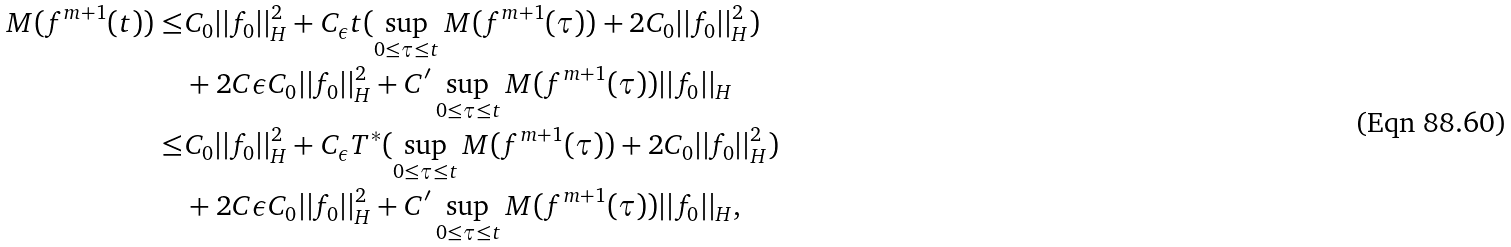Convert formula to latex. <formula><loc_0><loc_0><loc_500><loc_500>M ( f ^ { m + 1 } ( t ) ) \leq & C _ { 0 } | | f _ { 0 } | | ^ { 2 } _ { H } + C _ { \epsilon } t ( \sup _ { 0 \leq \tau \leq t } M ( f ^ { m + 1 } ( \tau ) ) + 2 C _ { 0 } | | f _ { 0 } | | ^ { 2 } _ { H } ) \\ & + 2 C \epsilon C _ { 0 } | | f _ { 0 } | | ^ { 2 } _ { H } + C ^ { \prime } \sup _ { 0 \leq \tau \leq t } M ( f ^ { m + 1 } ( \tau ) ) | | f _ { 0 } | | _ { H } \\ \leq & C _ { 0 } | | f _ { 0 } | | ^ { 2 } _ { H } + C _ { \epsilon } T ^ { * } ( \sup _ { 0 \leq \tau \leq t } M ( f ^ { m + 1 } ( \tau ) ) + 2 C _ { 0 } | | f _ { 0 } | | ^ { 2 } _ { H } ) \\ & + 2 C \epsilon C _ { 0 } | | f _ { 0 } | | ^ { 2 } _ { H } + C ^ { \prime } \sup _ { 0 \leq \tau \leq t } M ( f ^ { m + 1 } ( \tau ) ) | | f _ { 0 } | | _ { H } , \\</formula> 